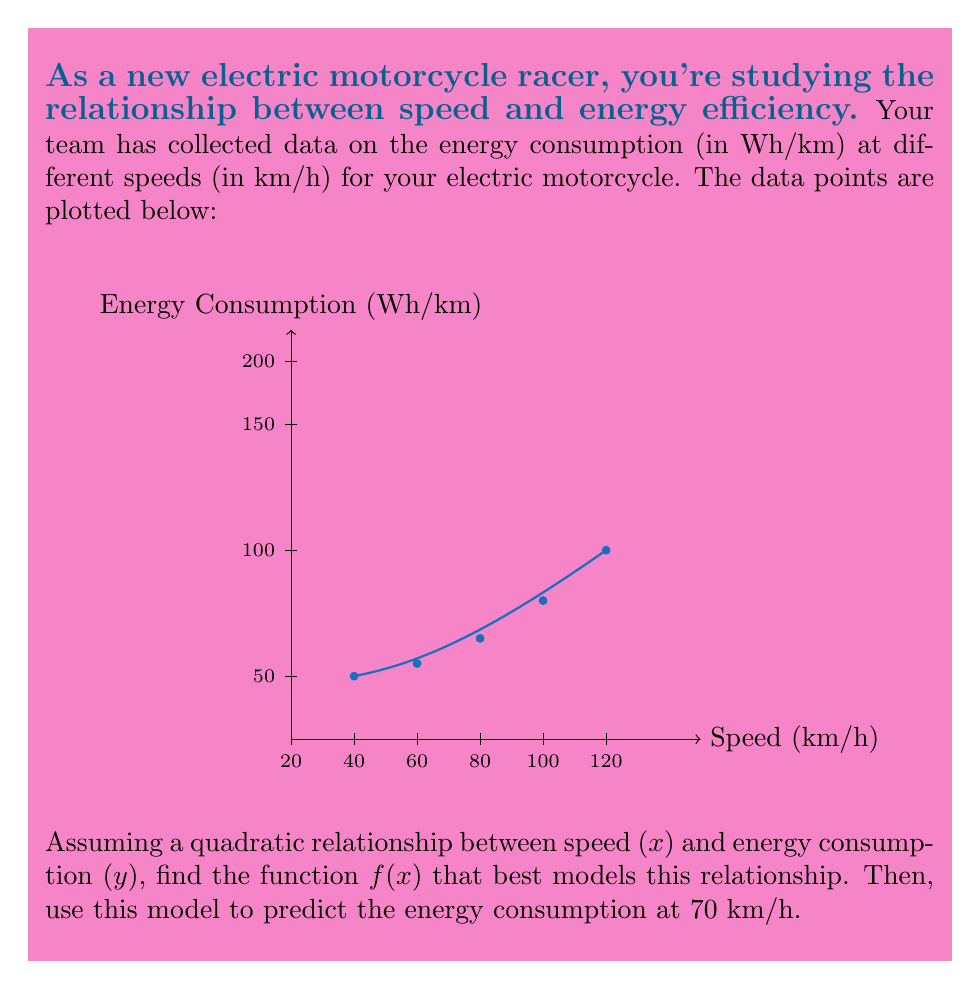Could you help me with this problem? Let's approach this step-by-step:

1) We assume a quadratic relationship of the form:
   $$f(x) = ax^2 + bx + c$$

2) To find $a$, $b$, and $c$, we need to solve a system of equations. Let's use three points: (20, 50), (60, 80), and (100, 150).

3) Substituting these points into our equation:
   $$50 = 400a + 20b + c$$
   $$80 = 3600a + 60b + c$$
   $$150 = 10000a + 100b + c$$

4) Subtracting the first equation from the second and third:
   $$30 = 3200a + 40b$$
   $$100 = 9600a + 80b$$

5) Multiplying the first of these by 2 and subtracting from the second:
   $$40 = 3200a$$
   $$a = \frac{1}{80} = 0.0125$$

6) Substituting this back into $30 = 3200a + 40b$:
   $$30 = 40 + 40b$$
   $$b = -\frac{1}{4} = -0.25$$

7) Using these in the first equation:
   $$50 = 400(0.0125) + 20(-0.25) + c$$
   $$50 = 5 - 5 + c$$
   $$c = 50$$

8) Therefore, our model is:
   $$f(x) = 0.0125x^2 - 0.25x + 50$$

9) To predict energy consumption at 70 km/h, we substitute $x = 70$:
   $$f(70) = 0.0125(70)^2 - 0.25(70) + 50$$
   $$= 61.25 - 17.5 + 50 = 93.75$$

Thus, the predicted energy consumption at 70 km/h is 93.75 Wh/km.
Answer: $f(x) = 0.0125x^2 - 0.25x + 50$; 93.75 Wh/km at 70 km/h 